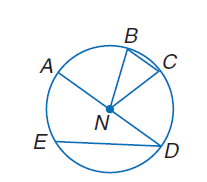Answer the mathemtical geometry problem and directly provide the correct option letter.
Question: If A N is 5 meters long, find the exact circumference of \odot N.
Choices: A: \pi B: 10 C: 5 \pi D: 10 \pi D 